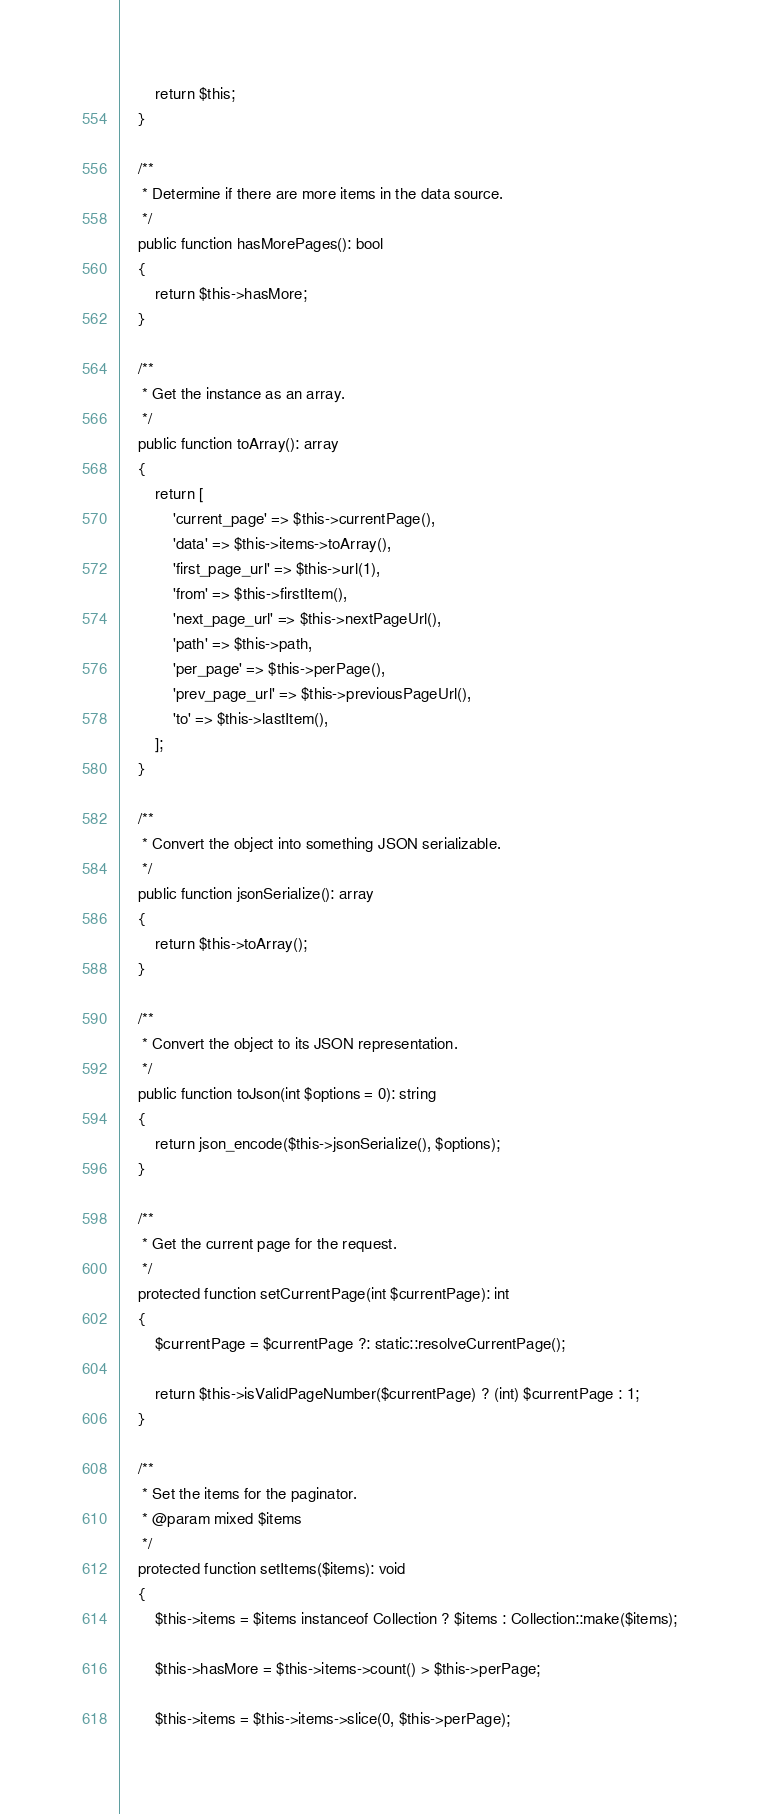Convert code to text. <code><loc_0><loc_0><loc_500><loc_500><_PHP_>
        return $this;
    }

    /**
     * Determine if there are more items in the data source.
     */
    public function hasMorePages(): bool
    {
        return $this->hasMore;
    }

    /**
     * Get the instance as an array.
     */
    public function toArray(): array
    {
        return [
            'current_page' => $this->currentPage(),
            'data' => $this->items->toArray(),
            'first_page_url' => $this->url(1),
            'from' => $this->firstItem(),
            'next_page_url' => $this->nextPageUrl(),
            'path' => $this->path,
            'per_page' => $this->perPage(),
            'prev_page_url' => $this->previousPageUrl(),
            'to' => $this->lastItem(),
        ];
    }

    /**
     * Convert the object into something JSON serializable.
     */
    public function jsonSerialize(): array
    {
        return $this->toArray();
    }

    /**
     * Convert the object to its JSON representation.
     */
    public function toJson(int $options = 0): string
    {
        return json_encode($this->jsonSerialize(), $options);
    }

    /**
     * Get the current page for the request.
     */
    protected function setCurrentPage(int $currentPage): int
    {
        $currentPage = $currentPage ?: static::resolveCurrentPage();

        return $this->isValidPageNumber($currentPage) ? (int) $currentPage : 1;
    }

    /**
     * Set the items for the paginator.
     * @param mixed $items
     */
    protected function setItems($items): void
    {
        $this->items = $items instanceof Collection ? $items : Collection::make($items);

        $this->hasMore = $this->items->count() > $this->perPage;

        $this->items = $this->items->slice(0, $this->perPage);</code> 